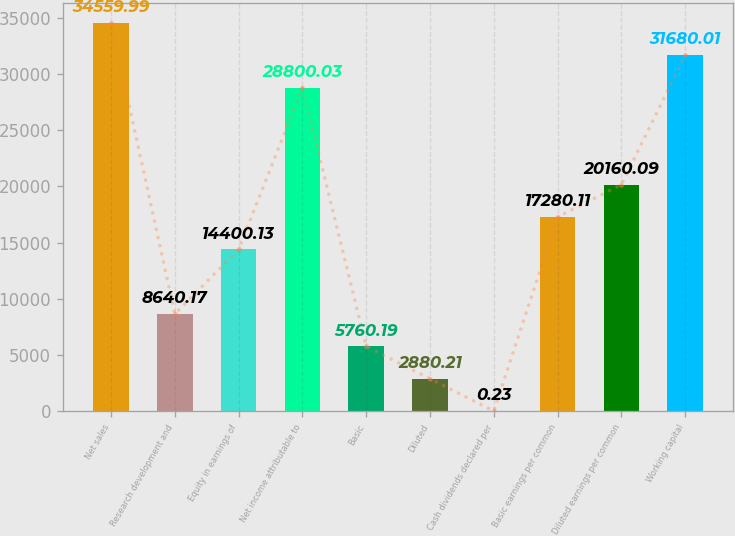<chart> <loc_0><loc_0><loc_500><loc_500><bar_chart><fcel>Net sales<fcel>Research development and<fcel>Equity in earnings of<fcel>Net income attributable to<fcel>Basic<fcel>Diluted<fcel>Cash dividends declared per<fcel>Basic earnings per common<fcel>Diluted earnings per common<fcel>Working capital<nl><fcel>34560<fcel>8640.17<fcel>14400.1<fcel>28800<fcel>5760.19<fcel>2880.21<fcel>0.23<fcel>17280.1<fcel>20160.1<fcel>31680<nl></chart> 